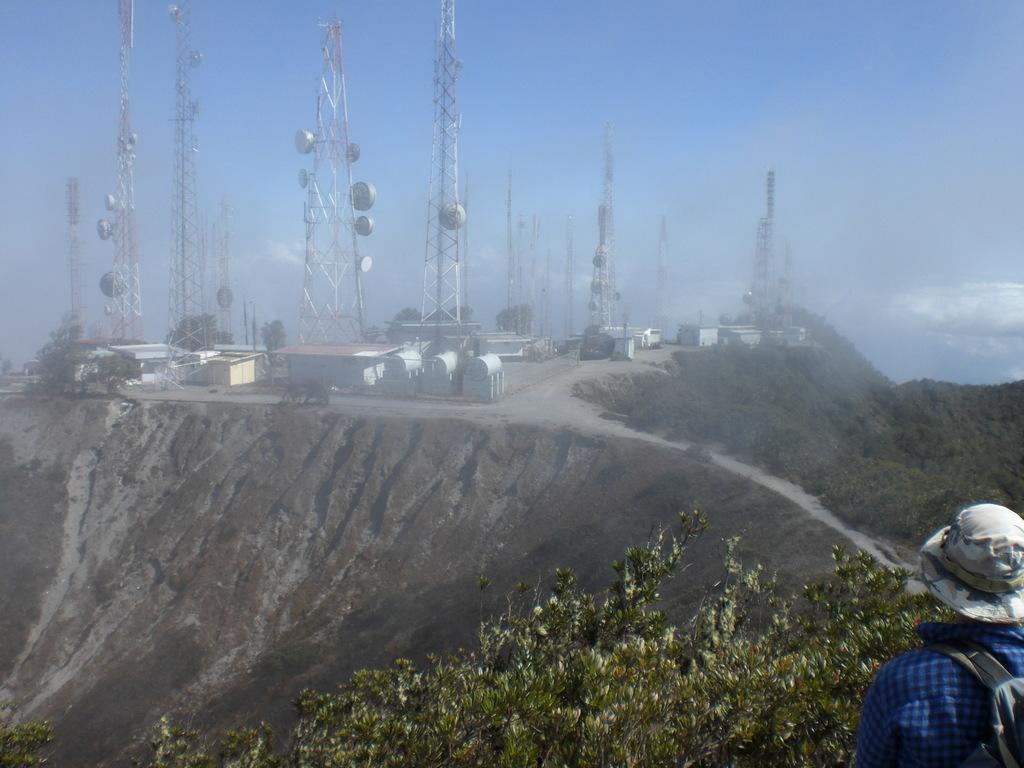How would you summarize this image in a sentence or two? In the picture we can see a person wearing a bag and a hat, the person is looking towards the hill on it we can see some power plants and towers and we can also see a plant and a sky. 